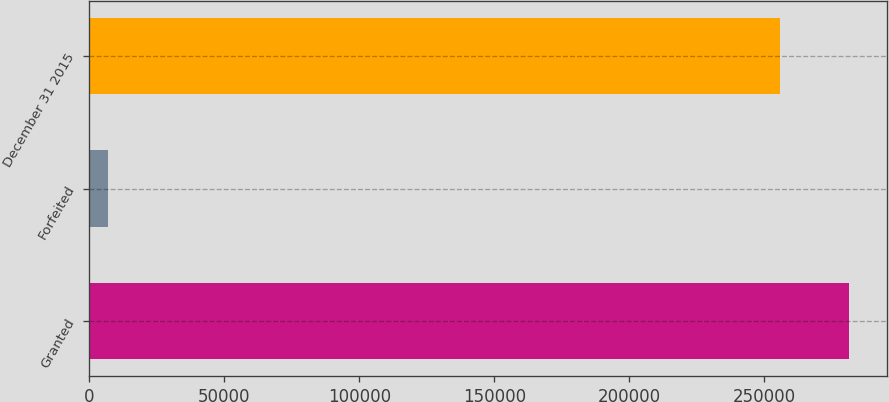Convert chart to OTSL. <chart><loc_0><loc_0><loc_500><loc_500><bar_chart><fcel>Granted<fcel>Forfeited<fcel>December 31 2015<nl><fcel>281455<fcel>6979<fcel>255868<nl></chart> 